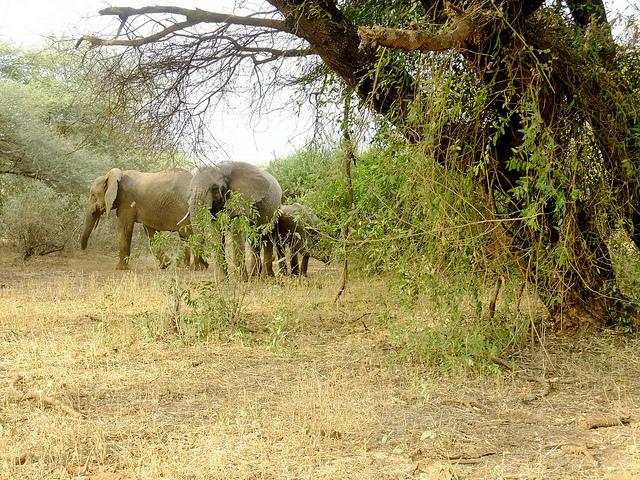How many elephants are huddled together on the left side of the hanging tree? three 